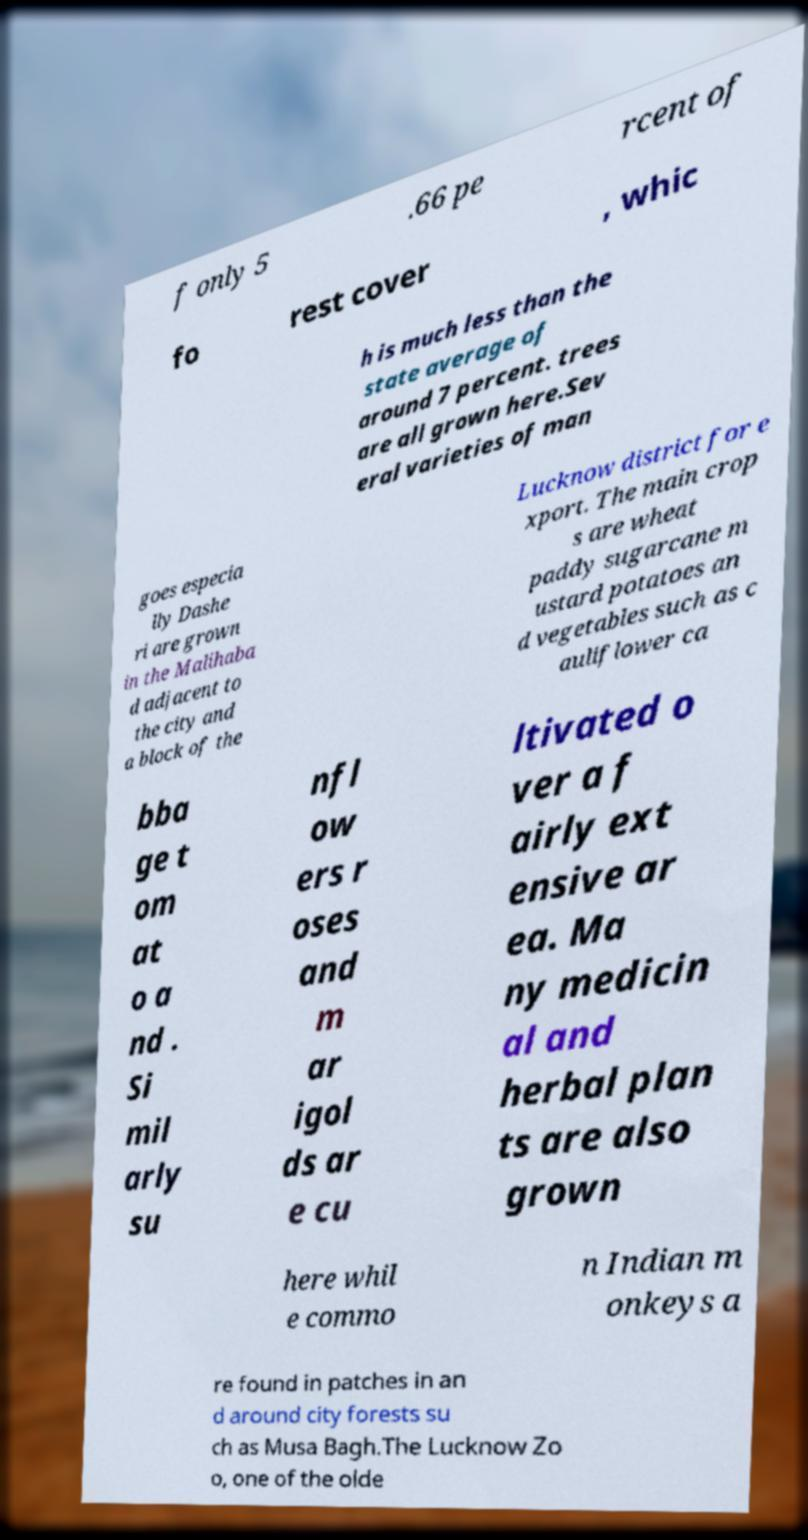Can you read and provide the text displayed in the image?This photo seems to have some interesting text. Can you extract and type it out for me? f only 5 .66 pe rcent of fo rest cover , whic h is much less than the state average of around 7 percent. trees are all grown here.Sev eral varieties of man goes especia lly Dashe ri are grown in the Malihaba d adjacent to the city and a block of the Lucknow district for e xport. The main crop s are wheat paddy sugarcane m ustard potatoes an d vegetables such as c auliflower ca bba ge t om at o a nd . Si mil arly su nfl ow ers r oses and m ar igol ds ar e cu ltivated o ver a f airly ext ensive ar ea. Ma ny medicin al and herbal plan ts are also grown here whil e commo n Indian m onkeys a re found in patches in an d around city forests su ch as Musa Bagh.The Lucknow Zo o, one of the olde 